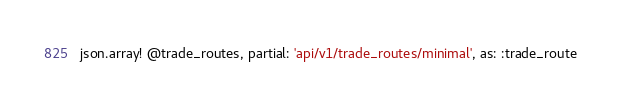<code> <loc_0><loc_0><loc_500><loc_500><_Ruby_>json.array! @trade_routes, partial: 'api/v1/trade_routes/minimal', as: :trade_route
</code> 